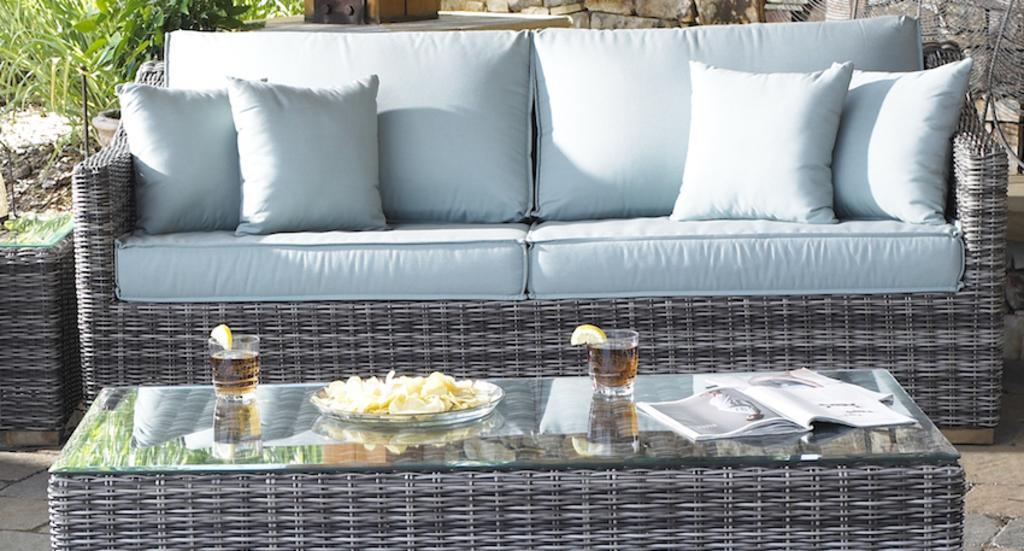Describe this image in one or two sentences. in this image there is one big sofa and table and teapoy is there on the floor and on table there are some books,some glass and some plant are also there and behind the sofa there are some plants is there and some cushions and some pillows there on the sofa and the background is sunny. 